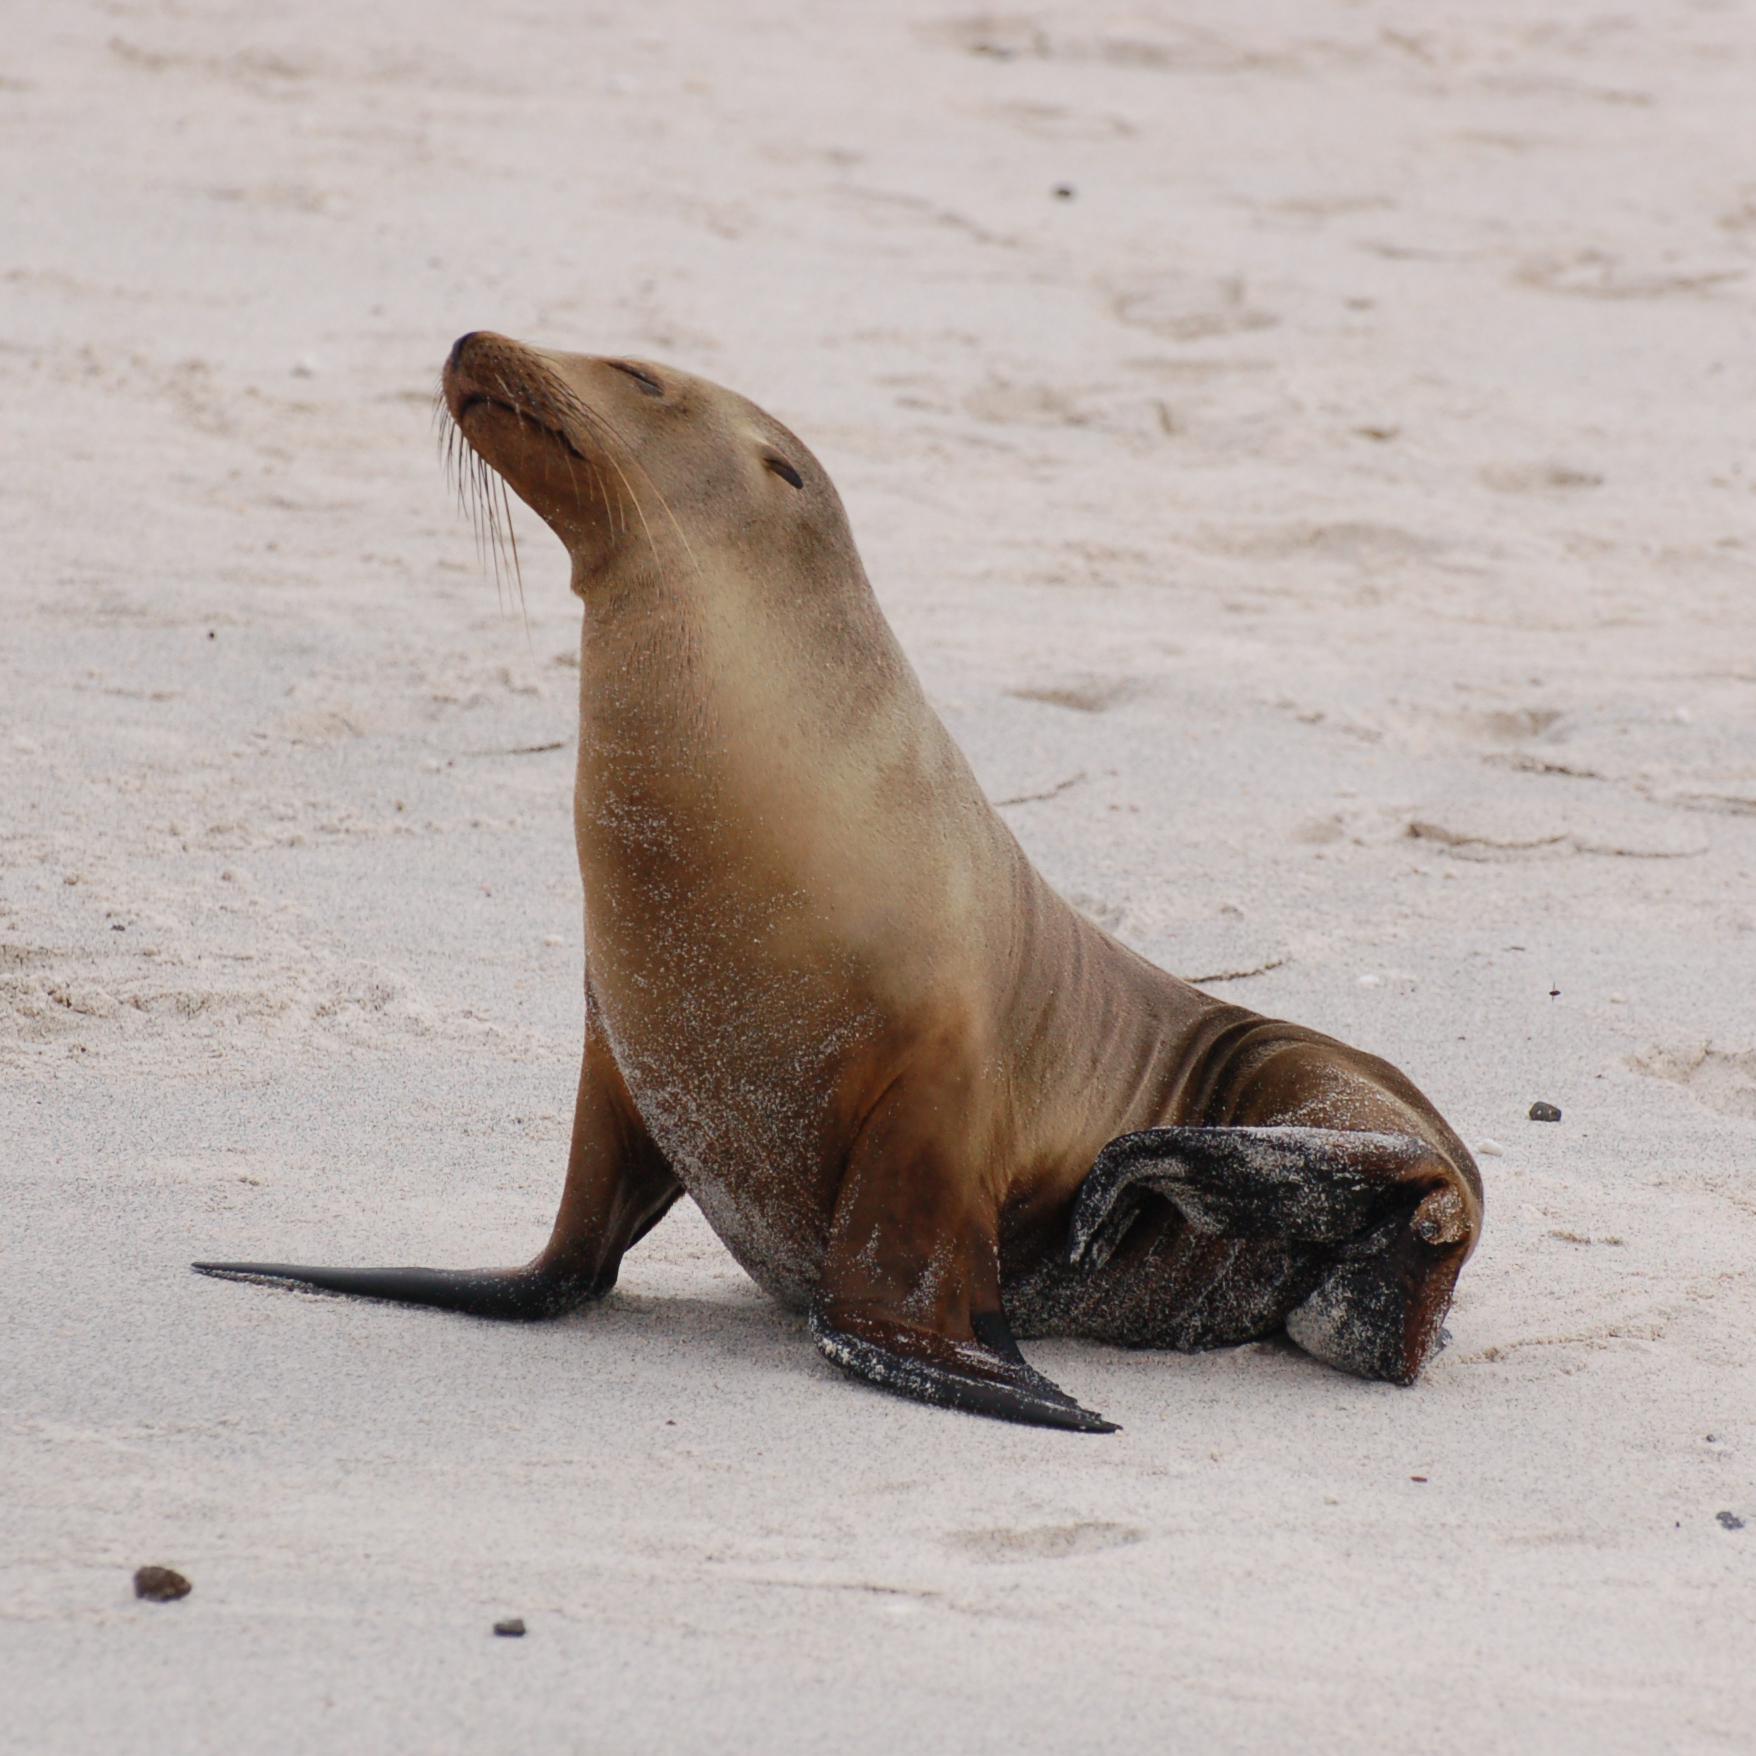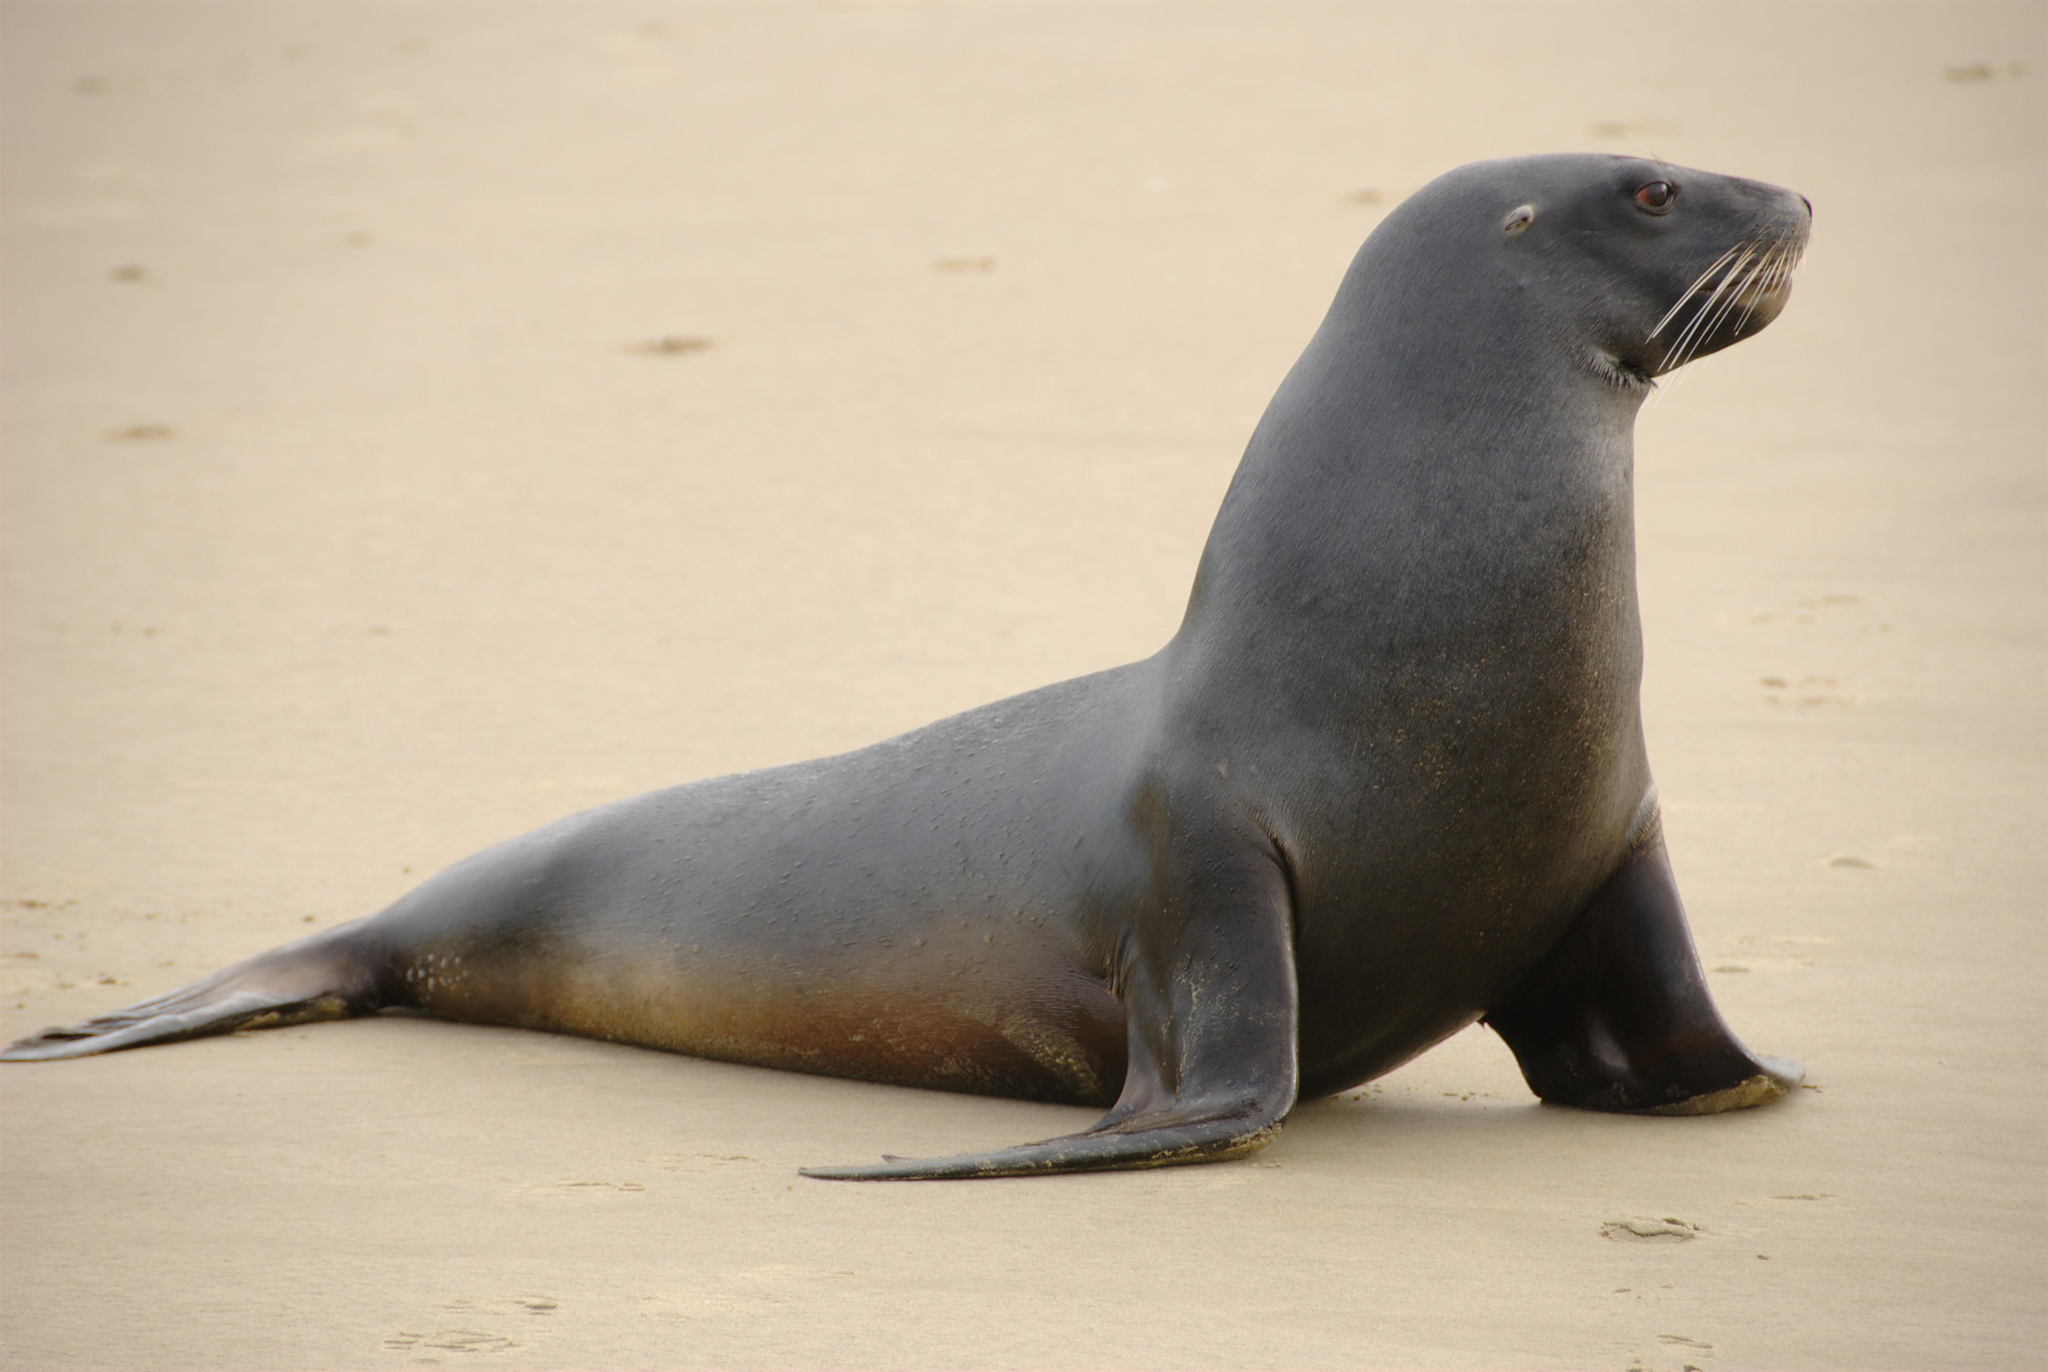The first image is the image on the left, the second image is the image on the right. Considering the images on both sides, is "In one image, there is a seal that appears to be looking directly at the camera." valid? Answer yes or no. No. 